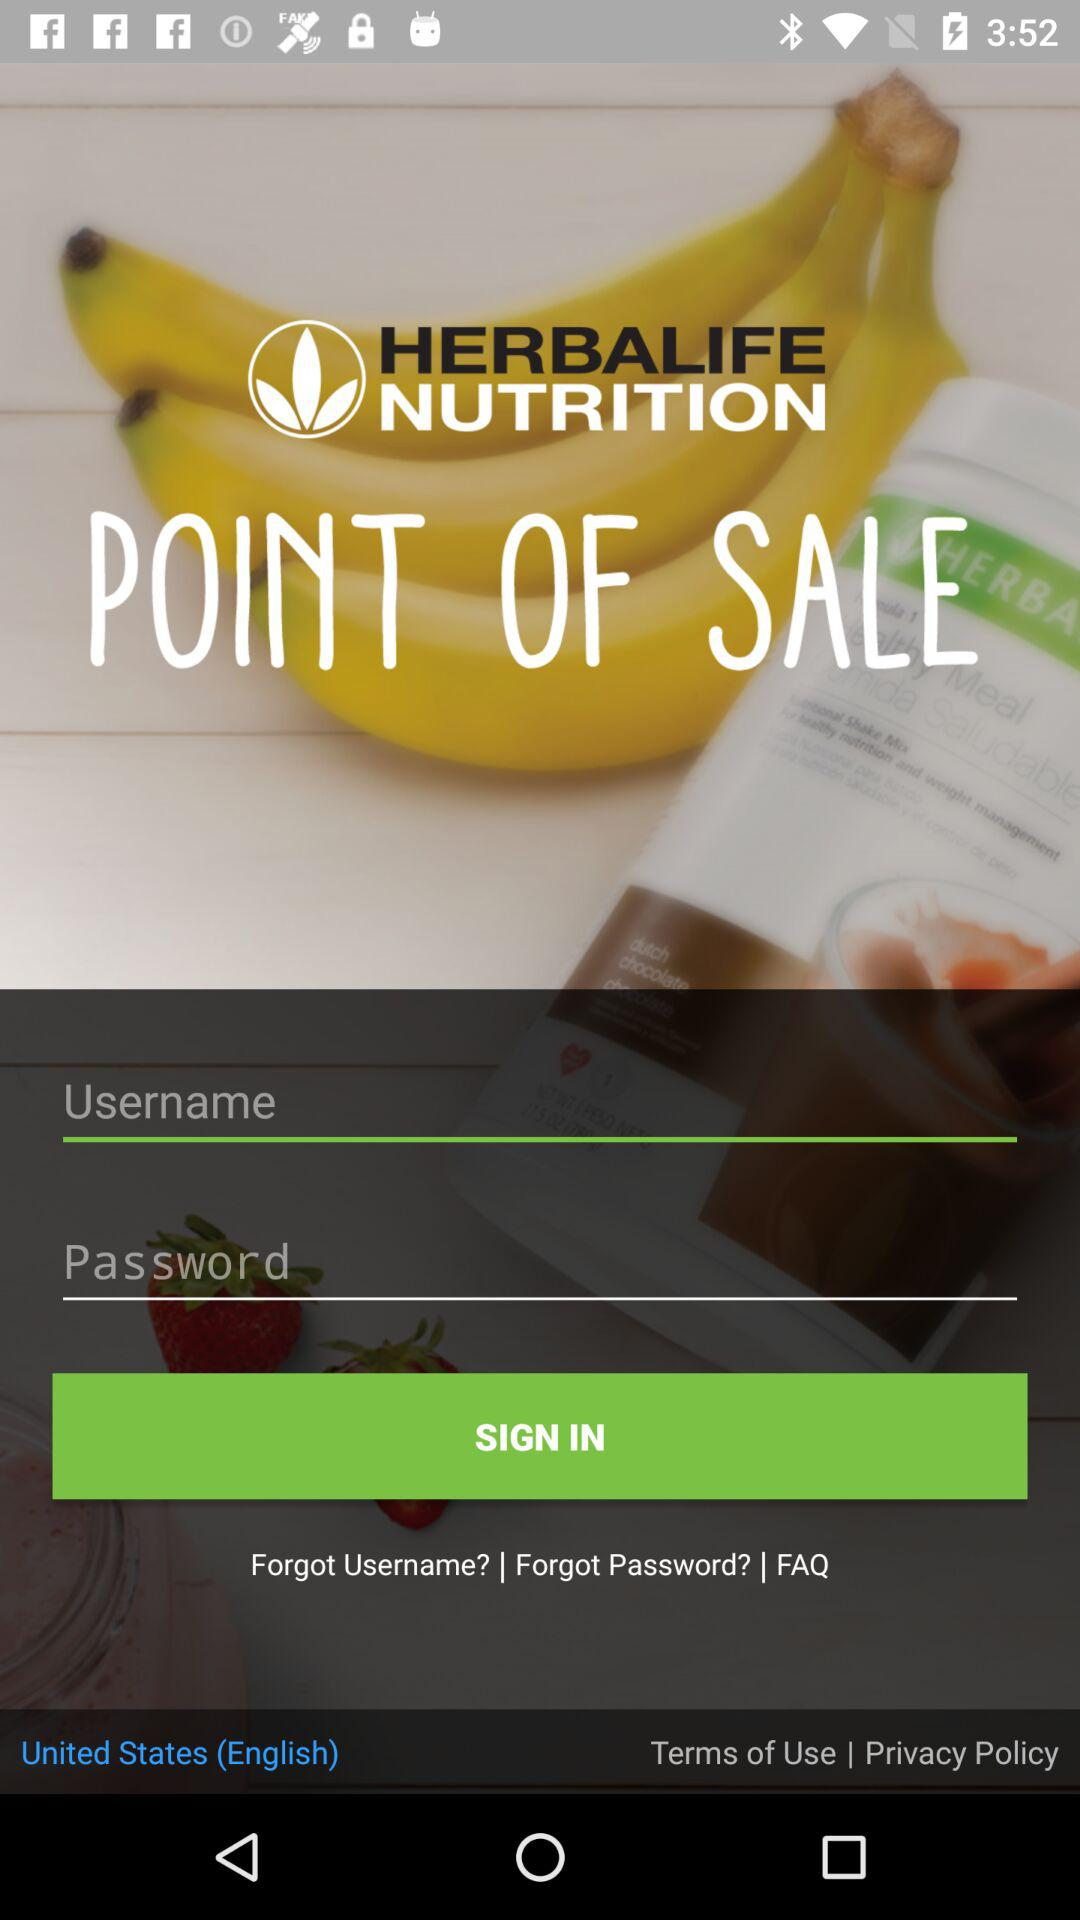What is the application's name? The application's name is "HERBALIFE NUTRITION". 